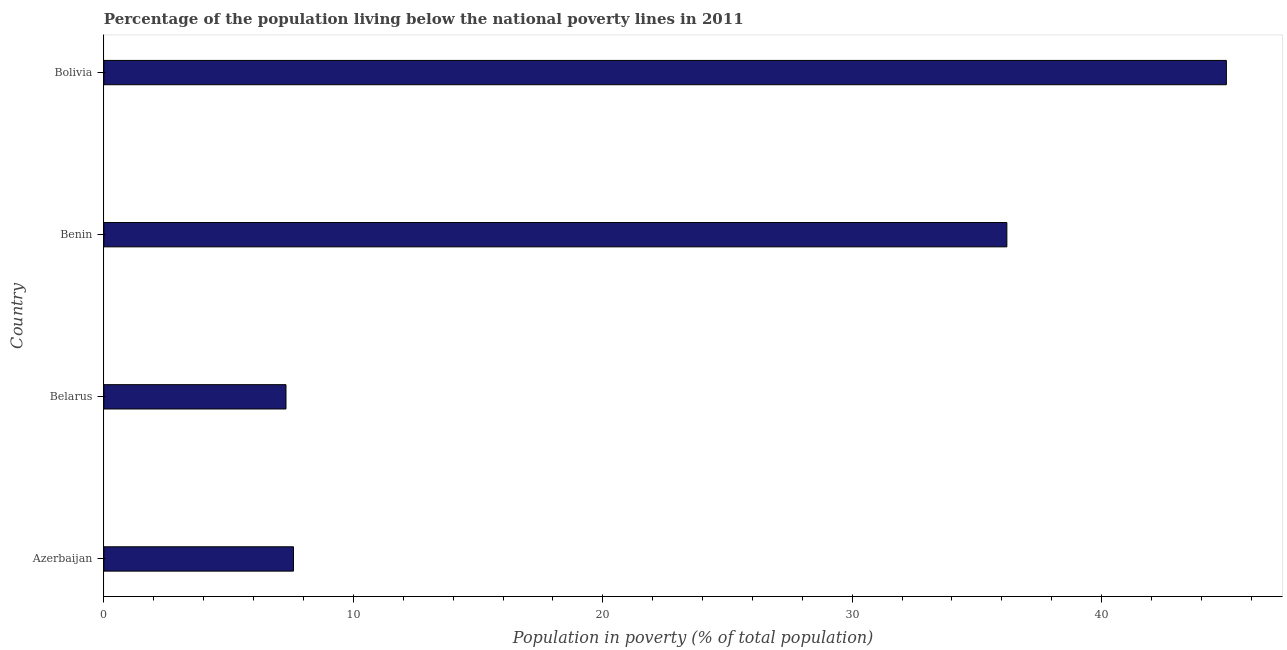Does the graph contain grids?
Provide a succinct answer. No. What is the title of the graph?
Provide a short and direct response. Percentage of the population living below the national poverty lines in 2011. What is the label or title of the X-axis?
Keep it short and to the point. Population in poverty (% of total population). What is the percentage of population living below poverty line in Belarus?
Your response must be concise. 7.3. Across all countries, what is the minimum percentage of population living below poverty line?
Provide a short and direct response. 7.3. In which country was the percentage of population living below poverty line maximum?
Provide a short and direct response. Bolivia. In which country was the percentage of population living below poverty line minimum?
Your answer should be very brief. Belarus. What is the sum of the percentage of population living below poverty line?
Your answer should be very brief. 96.1. What is the average percentage of population living below poverty line per country?
Your response must be concise. 24.02. What is the median percentage of population living below poverty line?
Provide a succinct answer. 21.9. What is the ratio of the percentage of population living below poverty line in Belarus to that in Bolivia?
Offer a very short reply. 0.16. Is the percentage of population living below poverty line in Azerbaijan less than that in Belarus?
Keep it short and to the point. No. What is the difference between the highest and the second highest percentage of population living below poverty line?
Provide a short and direct response. 8.8. What is the difference between the highest and the lowest percentage of population living below poverty line?
Your response must be concise. 37.7. In how many countries, is the percentage of population living below poverty line greater than the average percentage of population living below poverty line taken over all countries?
Make the answer very short. 2. How many bars are there?
Provide a short and direct response. 4. What is the Population in poverty (% of total population) in Benin?
Ensure brevity in your answer.  36.2. What is the difference between the Population in poverty (% of total population) in Azerbaijan and Benin?
Ensure brevity in your answer.  -28.6. What is the difference between the Population in poverty (% of total population) in Azerbaijan and Bolivia?
Your answer should be compact. -37.4. What is the difference between the Population in poverty (% of total population) in Belarus and Benin?
Ensure brevity in your answer.  -28.9. What is the difference between the Population in poverty (% of total population) in Belarus and Bolivia?
Offer a very short reply. -37.7. What is the difference between the Population in poverty (% of total population) in Benin and Bolivia?
Your answer should be compact. -8.8. What is the ratio of the Population in poverty (% of total population) in Azerbaijan to that in Belarus?
Provide a succinct answer. 1.04. What is the ratio of the Population in poverty (% of total population) in Azerbaijan to that in Benin?
Your answer should be compact. 0.21. What is the ratio of the Population in poverty (% of total population) in Azerbaijan to that in Bolivia?
Your answer should be very brief. 0.17. What is the ratio of the Population in poverty (% of total population) in Belarus to that in Benin?
Ensure brevity in your answer.  0.2. What is the ratio of the Population in poverty (% of total population) in Belarus to that in Bolivia?
Your response must be concise. 0.16. What is the ratio of the Population in poverty (% of total population) in Benin to that in Bolivia?
Keep it short and to the point. 0.8. 